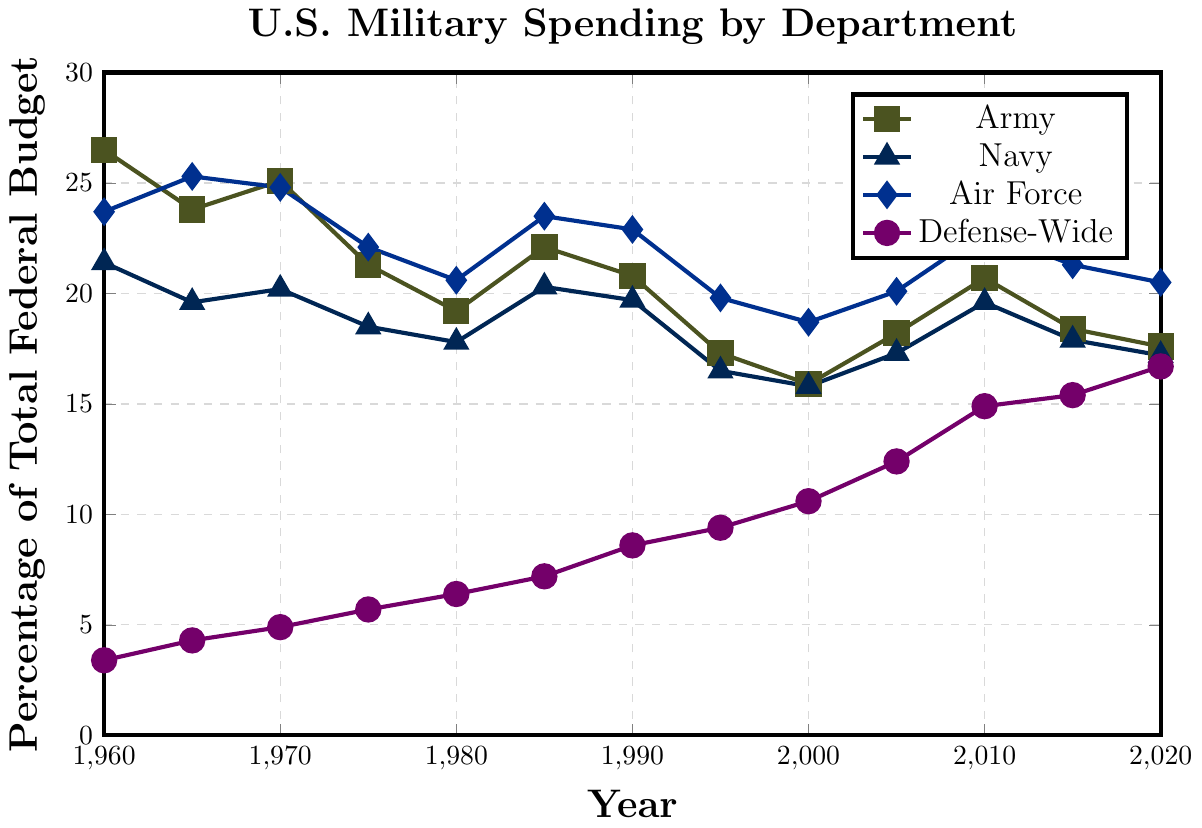When did the Defense-Wide spending surpass the Army spending? To find when Defense-Wide spending surpassed the Army, look for the point where the purple line is above the green line after being below. As per the data, this happens sometime between 2000 and 2005.
Answer: Between 2000 and 2005 Which department had the most fluctuation in spending as a percentage of the total federal budget? To determine which department had the most fluctuation, analyze the line with the highest variance across the years. The Army (green) line has several significant rises and falls.
Answer: Army In which year was Navy spending within 1 percentage point of Army spending? Look for the closest points between the Navy (blue) and the Army (green) lines. In 2015, Army is at 18.4% and Navy is at 17.9%, which is within 1 percentage point.
Answer: 2015 What is the average Air Force spending from 1960 to 2020? Calculate the average of the Air Force spending percentages from the given years: (23.7 + 25.3 + 24.8 + 22.1 + 20.6 + 23.5 + 22.9 + 19.8 + 18.7 + 20.1 + 22.8 + 21.3 + 20.5) / 13. Sum is 266.1. Average is 266.1 / 13.
Answer: 20.47% Which department had the least spending in 1980? Check the 1980 values for each department. Army: 19.2%, Navy: 17.8%, Air Force: 20.6%, Defense-Wide: 6.4%. Defense-Wide has the lowest percentage.
Answer: Defense-Wide From 1960 to 2020, did any department show a consistent increase every five years? Analyze each department's data over five-year intervals. Defense-Wide (purple), despite some fluctuations, shows a general consistent increase from 3.4% in 1960 to 16.7% in 2020.
Answer: Defense-Wide In what year did the Air Force spend the highest as a percentage of the total federal budget? Identify the highest point in the Air Force (blue) line. The highest point is in 1965 at 25.3%.
Answer: 1965 Compare the percentage of the total federal budget spent on Defense-Wide in 1960 and 2020. By how much did it increase? Subtract 1960 Defense-Wide spending from 2020 Defense-Wide spending: 16.7% - 3.4% = 13.3%.
Answer: 13.3% What is the difference in Army spending between 1960 and 2020? Subtract 2020 Army spending from 1960 Army spending: 26.5% - 17.6% = 8.9%.
Answer: 8.9% Which department had the highest spending in 2010? Check the 2010 values for each department. Army: 20.7%, Navy: 19.6%, Air Force: 22.8%, Defense-Wide: 14.9%. The Air Force has the highest percentage.
Answer: Air Force 